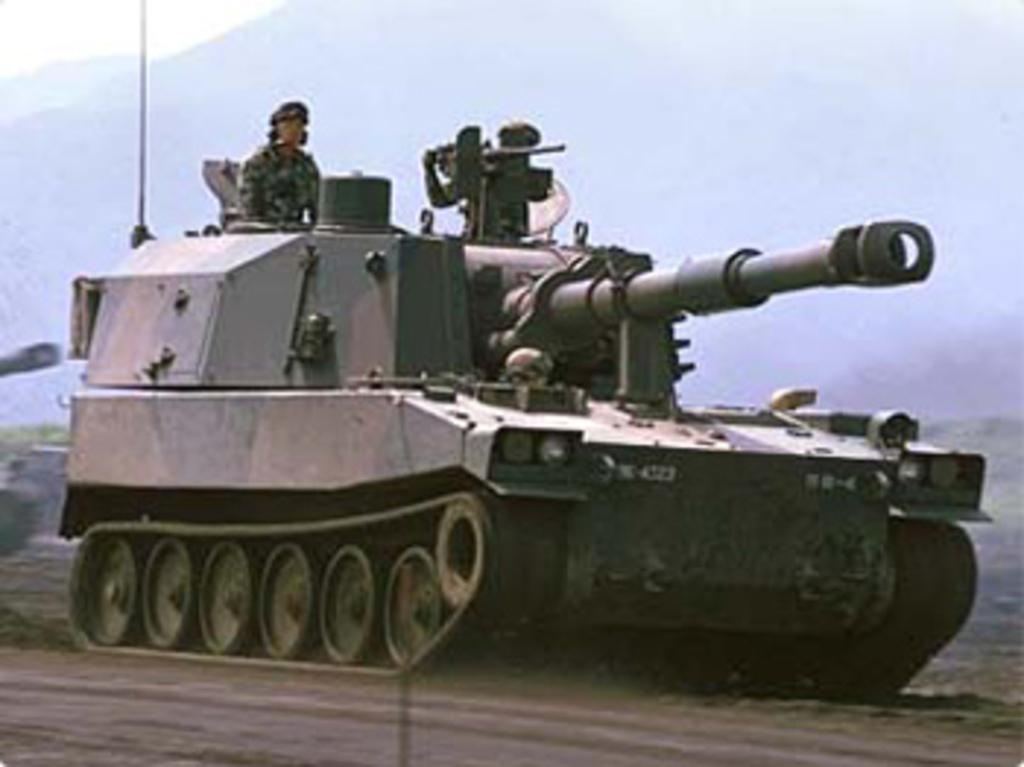How many people are in the image? There are two people in the image. What object is present in the image alongside the people? There is a tank in the image. Can you describe the background of the image? The background of the image is not clear. Can you see any ocean waves in the image? There is no ocean or waves present in the image. What type of vest is being worn by the people in the image? There is no vest visible in the image. 